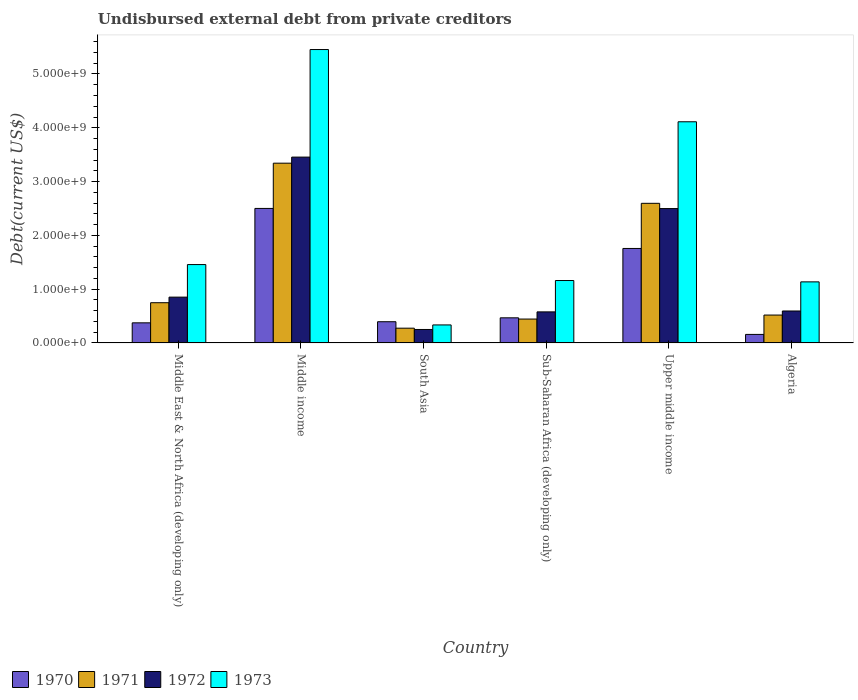How many different coloured bars are there?
Ensure brevity in your answer.  4. Are the number of bars on each tick of the X-axis equal?
Provide a succinct answer. Yes. What is the label of the 5th group of bars from the left?
Provide a short and direct response. Upper middle income. In how many cases, is the number of bars for a given country not equal to the number of legend labels?
Provide a short and direct response. 0. What is the total debt in 1973 in Algeria?
Provide a succinct answer. 1.14e+09. Across all countries, what is the maximum total debt in 1973?
Keep it short and to the point. 5.45e+09. Across all countries, what is the minimum total debt in 1971?
Provide a succinct answer. 2.74e+08. In which country was the total debt in 1972 minimum?
Your response must be concise. South Asia. What is the total total debt in 1971 in the graph?
Your answer should be very brief. 7.92e+09. What is the difference between the total debt in 1972 in Middle East & North Africa (developing only) and that in Upper middle income?
Your answer should be compact. -1.65e+09. What is the difference between the total debt in 1973 in South Asia and the total debt in 1972 in Middle East & North Africa (developing only)?
Provide a short and direct response. -5.17e+08. What is the average total debt in 1972 per country?
Keep it short and to the point. 1.37e+09. What is the difference between the total debt of/in 1970 and total debt of/in 1972 in Middle income?
Provide a succinct answer. -9.54e+08. In how many countries, is the total debt in 1972 greater than 3800000000 US$?
Make the answer very short. 0. What is the ratio of the total debt in 1972 in Middle East & North Africa (developing only) to that in Sub-Saharan Africa (developing only)?
Keep it short and to the point. 1.47. Is the total debt in 1971 in Middle East & North Africa (developing only) less than that in Upper middle income?
Offer a terse response. Yes. What is the difference between the highest and the second highest total debt in 1970?
Ensure brevity in your answer.  -7.44e+08. What is the difference between the highest and the lowest total debt in 1972?
Make the answer very short. 3.20e+09. In how many countries, is the total debt in 1970 greater than the average total debt in 1970 taken over all countries?
Your answer should be very brief. 2. What does the 3rd bar from the right in Middle East & North Africa (developing only) represents?
Provide a succinct answer. 1971. Is it the case that in every country, the sum of the total debt in 1971 and total debt in 1970 is greater than the total debt in 1972?
Provide a short and direct response. Yes. How many countries are there in the graph?
Your answer should be compact. 6. How many legend labels are there?
Make the answer very short. 4. How are the legend labels stacked?
Give a very brief answer. Horizontal. What is the title of the graph?
Give a very brief answer. Undisbursed external debt from private creditors. What is the label or title of the Y-axis?
Keep it short and to the point. Debt(current US$). What is the Debt(current US$) of 1970 in Middle East & North Africa (developing only)?
Provide a succinct answer. 3.74e+08. What is the Debt(current US$) in 1971 in Middle East & North Africa (developing only)?
Your answer should be compact. 7.48e+08. What is the Debt(current US$) in 1972 in Middle East & North Africa (developing only)?
Provide a short and direct response. 8.51e+08. What is the Debt(current US$) in 1973 in Middle East & North Africa (developing only)?
Keep it short and to the point. 1.46e+09. What is the Debt(current US$) in 1970 in Middle income?
Provide a succinct answer. 2.50e+09. What is the Debt(current US$) of 1971 in Middle income?
Ensure brevity in your answer.  3.34e+09. What is the Debt(current US$) in 1972 in Middle income?
Offer a terse response. 3.45e+09. What is the Debt(current US$) of 1973 in Middle income?
Offer a terse response. 5.45e+09. What is the Debt(current US$) of 1970 in South Asia?
Your response must be concise. 3.94e+08. What is the Debt(current US$) in 1971 in South Asia?
Make the answer very short. 2.74e+08. What is the Debt(current US$) in 1972 in South Asia?
Ensure brevity in your answer.  2.50e+08. What is the Debt(current US$) in 1973 in South Asia?
Give a very brief answer. 3.35e+08. What is the Debt(current US$) in 1970 in Sub-Saharan Africa (developing only)?
Your answer should be very brief. 4.67e+08. What is the Debt(current US$) in 1971 in Sub-Saharan Africa (developing only)?
Provide a short and direct response. 4.44e+08. What is the Debt(current US$) of 1972 in Sub-Saharan Africa (developing only)?
Offer a terse response. 5.77e+08. What is the Debt(current US$) in 1973 in Sub-Saharan Africa (developing only)?
Give a very brief answer. 1.16e+09. What is the Debt(current US$) of 1970 in Upper middle income?
Your answer should be very brief. 1.76e+09. What is the Debt(current US$) of 1971 in Upper middle income?
Your response must be concise. 2.60e+09. What is the Debt(current US$) in 1972 in Upper middle income?
Your response must be concise. 2.50e+09. What is the Debt(current US$) in 1973 in Upper middle income?
Keep it short and to the point. 4.11e+09. What is the Debt(current US$) of 1970 in Algeria?
Ensure brevity in your answer.  1.59e+08. What is the Debt(current US$) of 1971 in Algeria?
Your answer should be very brief. 5.18e+08. What is the Debt(current US$) of 1972 in Algeria?
Provide a short and direct response. 5.94e+08. What is the Debt(current US$) in 1973 in Algeria?
Provide a succinct answer. 1.14e+09. Across all countries, what is the maximum Debt(current US$) of 1970?
Your response must be concise. 2.50e+09. Across all countries, what is the maximum Debt(current US$) of 1971?
Provide a succinct answer. 3.34e+09. Across all countries, what is the maximum Debt(current US$) in 1972?
Offer a very short reply. 3.45e+09. Across all countries, what is the maximum Debt(current US$) of 1973?
Your response must be concise. 5.45e+09. Across all countries, what is the minimum Debt(current US$) of 1970?
Your answer should be compact. 1.59e+08. Across all countries, what is the minimum Debt(current US$) of 1971?
Provide a short and direct response. 2.74e+08. Across all countries, what is the minimum Debt(current US$) in 1972?
Ensure brevity in your answer.  2.50e+08. Across all countries, what is the minimum Debt(current US$) in 1973?
Make the answer very short. 3.35e+08. What is the total Debt(current US$) of 1970 in the graph?
Your answer should be very brief. 5.65e+09. What is the total Debt(current US$) of 1971 in the graph?
Offer a very short reply. 7.92e+09. What is the total Debt(current US$) of 1972 in the graph?
Provide a succinct answer. 8.23e+09. What is the total Debt(current US$) of 1973 in the graph?
Offer a terse response. 1.37e+1. What is the difference between the Debt(current US$) in 1970 in Middle East & North Africa (developing only) and that in Middle income?
Make the answer very short. -2.13e+09. What is the difference between the Debt(current US$) in 1971 in Middle East & North Africa (developing only) and that in Middle income?
Ensure brevity in your answer.  -2.59e+09. What is the difference between the Debt(current US$) of 1972 in Middle East & North Africa (developing only) and that in Middle income?
Your answer should be very brief. -2.60e+09. What is the difference between the Debt(current US$) of 1973 in Middle East & North Africa (developing only) and that in Middle income?
Give a very brief answer. -4.00e+09. What is the difference between the Debt(current US$) in 1970 in Middle East & North Africa (developing only) and that in South Asia?
Offer a terse response. -2.07e+07. What is the difference between the Debt(current US$) in 1971 in Middle East & North Africa (developing only) and that in South Asia?
Provide a short and direct response. 4.74e+08. What is the difference between the Debt(current US$) in 1972 in Middle East & North Africa (developing only) and that in South Asia?
Provide a succinct answer. 6.01e+08. What is the difference between the Debt(current US$) in 1973 in Middle East & North Africa (developing only) and that in South Asia?
Ensure brevity in your answer.  1.12e+09. What is the difference between the Debt(current US$) in 1970 in Middle East & North Africa (developing only) and that in Sub-Saharan Africa (developing only)?
Offer a very short reply. -9.32e+07. What is the difference between the Debt(current US$) of 1971 in Middle East & North Africa (developing only) and that in Sub-Saharan Africa (developing only)?
Provide a succinct answer. 3.04e+08. What is the difference between the Debt(current US$) of 1972 in Middle East & North Africa (developing only) and that in Sub-Saharan Africa (developing only)?
Ensure brevity in your answer.  2.74e+08. What is the difference between the Debt(current US$) in 1973 in Middle East & North Africa (developing only) and that in Sub-Saharan Africa (developing only)?
Your answer should be compact. 2.97e+08. What is the difference between the Debt(current US$) of 1970 in Middle East & North Africa (developing only) and that in Upper middle income?
Your answer should be compact. -1.38e+09. What is the difference between the Debt(current US$) of 1971 in Middle East & North Africa (developing only) and that in Upper middle income?
Your response must be concise. -1.85e+09. What is the difference between the Debt(current US$) of 1972 in Middle East & North Africa (developing only) and that in Upper middle income?
Make the answer very short. -1.65e+09. What is the difference between the Debt(current US$) in 1973 in Middle East & North Africa (developing only) and that in Upper middle income?
Give a very brief answer. -2.65e+09. What is the difference between the Debt(current US$) in 1970 in Middle East & North Africa (developing only) and that in Algeria?
Make the answer very short. 2.15e+08. What is the difference between the Debt(current US$) of 1971 in Middle East & North Africa (developing only) and that in Algeria?
Give a very brief answer. 2.29e+08. What is the difference between the Debt(current US$) of 1972 in Middle East & North Africa (developing only) and that in Algeria?
Your answer should be very brief. 2.57e+08. What is the difference between the Debt(current US$) of 1973 in Middle East & North Africa (developing only) and that in Algeria?
Your answer should be compact. 3.22e+08. What is the difference between the Debt(current US$) of 1970 in Middle income and that in South Asia?
Provide a succinct answer. 2.11e+09. What is the difference between the Debt(current US$) of 1971 in Middle income and that in South Asia?
Offer a very short reply. 3.07e+09. What is the difference between the Debt(current US$) in 1972 in Middle income and that in South Asia?
Offer a terse response. 3.20e+09. What is the difference between the Debt(current US$) in 1973 in Middle income and that in South Asia?
Your response must be concise. 5.12e+09. What is the difference between the Debt(current US$) in 1970 in Middle income and that in Sub-Saharan Africa (developing only)?
Your response must be concise. 2.03e+09. What is the difference between the Debt(current US$) in 1971 in Middle income and that in Sub-Saharan Africa (developing only)?
Provide a short and direct response. 2.90e+09. What is the difference between the Debt(current US$) of 1972 in Middle income and that in Sub-Saharan Africa (developing only)?
Offer a terse response. 2.88e+09. What is the difference between the Debt(current US$) of 1973 in Middle income and that in Sub-Saharan Africa (developing only)?
Your answer should be compact. 4.29e+09. What is the difference between the Debt(current US$) of 1970 in Middle income and that in Upper middle income?
Your answer should be very brief. 7.44e+08. What is the difference between the Debt(current US$) in 1971 in Middle income and that in Upper middle income?
Ensure brevity in your answer.  7.46e+08. What is the difference between the Debt(current US$) of 1972 in Middle income and that in Upper middle income?
Keep it short and to the point. 9.57e+08. What is the difference between the Debt(current US$) of 1973 in Middle income and that in Upper middle income?
Offer a terse response. 1.34e+09. What is the difference between the Debt(current US$) in 1970 in Middle income and that in Algeria?
Offer a terse response. 2.34e+09. What is the difference between the Debt(current US$) in 1971 in Middle income and that in Algeria?
Your answer should be compact. 2.82e+09. What is the difference between the Debt(current US$) in 1972 in Middle income and that in Algeria?
Ensure brevity in your answer.  2.86e+09. What is the difference between the Debt(current US$) of 1973 in Middle income and that in Algeria?
Provide a succinct answer. 4.32e+09. What is the difference between the Debt(current US$) in 1970 in South Asia and that in Sub-Saharan Africa (developing only)?
Provide a succinct answer. -7.26e+07. What is the difference between the Debt(current US$) of 1971 in South Asia and that in Sub-Saharan Africa (developing only)?
Offer a terse response. -1.70e+08. What is the difference between the Debt(current US$) of 1972 in South Asia and that in Sub-Saharan Africa (developing only)?
Provide a succinct answer. -3.27e+08. What is the difference between the Debt(current US$) of 1973 in South Asia and that in Sub-Saharan Africa (developing only)?
Make the answer very short. -8.26e+08. What is the difference between the Debt(current US$) in 1970 in South Asia and that in Upper middle income?
Keep it short and to the point. -1.36e+09. What is the difference between the Debt(current US$) in 1971 in South Asia and that in Upper middle income?
Ensure brevity in your answer.  -2.32e+09. What is the difference between the Debt(current US$) in 1972 in South Asia and that in Upper middle income?
Ensure brevity in your answer.  -2.25e+09. What is the difference between the Debt(current US$) of 1973 in South Asia and that in Upper middle income?
Offer a terse response. -3.78e+09. What is the difference between the Debt(current US$) in 1970 in South Asia and that in Algeria?
Make the answer very short. 2.36e+08. What is the difference between the Debt(current US$) in 1971 in South Asia and that in Algeria?
Make the answer very short. -2.44e+08. What is the difference between the Debt(current US$) in 1972 in South Asia and that in Algeria?
Offer a very short reply. -3.44e+08. What is the difference between the Debt(current US$) of 1973 in South Asia and that in Algeria?
Ensure brevity in your answer.  -8.00e+08. What is the difference between the Debt(current US$) in 1970 in Sub-Saharan Africa (developing only) and that in Upper middle income?
Provide a succinct answer. -1.29e+09. What is the difference between the Debt(current US$) of 1971 in Sub-Saharan Africa (developing only) and that in Upper middle income?
Offer a very short reply. -2.15e+09. What is the difference between the Debt(current US$) of 1972 in Sub-Saharan Africa (developing only) and that in Upper middle income?
Offer a very short reply. -1.92e+09. What is the difference between the Debt(current US$) in 1973 in Sub-Saharan Africa (developing only) and that in Upper middle income?
Ensure brevity in your answer.  -2.95e+09. What is the difference between the Debt(current US$) of 1970 in Sub-Saharan Africa (developing only) and that in Algeria?
Keep it short and to the point. 3.08e+08. What is the difference between the Debt(current US$) of 1971 in Sub-Saharan Africa (developing only) and that in Algeria?
Your response must be concise. -7.44e+07. What is the difference between the Debt(current US$) in 1972 in Sub-Saharan Africa (developing only) and that in Algeria?
Offer a terse response. -1.64e+07. What is the difference between the Debt(current US$) of 1973 in Sub-Saharan Africa (developing only) and that in Algeria?
Your response must be concise. 2.52e+07. What is the difference between the Debt(current US$) of 1970 in Upper middle income and that in Algeria?
Your response must be concise. 1.60e+09. What is the difference between the Debt(current US$) in 1971 in Upper middle income and that in Algeria?
Your answer should be very brief. 2.08e+09. What is the difference between the Debt(current US$) of 1972 in Upper middle income and that in Algeria?
Your answer should be compact. 1.90e+09. What is the difference between the Debt(current US$) of 1973 in Upper middle income and that in Algeria?
Give a very brief answer. 2.98e+09. What is the difference between the Debt(current US$) of 1970 in Middle East & North Africa (developing only) and the Debt(current US$) of 1971 in Middle income?
Ensure brevity in your answer.  -2.97e+09. What is the difference between the Debt(current US$) in 1970 in Middle East & North Africa (developing only) and the Debt(current US$) in 1972 in Middle income?
Offer a terse response. -3.08e+09. What is the difference between the Debt(current US$) of 1970 in Middle East & North Africa (developing only) and the Debt(current US$) of 1973 in Middle income?
Offer a terse response. -5.08e+09. What is the difference between the Debt(current US$) in 1971 in Middle East & North Africa (developing only) and the Debt(current US$) in 1972 in Middle income?
Ensure brevity in your answer.  -2.71e+09. What is the difference between the Debt(current US$) of 1971 in Middle East & North Africa (developing only) and the Debt(current US$) of 1973 in Middle income?
Keep it short and to the point. -4.71e+09. What is the difference between the Debt(current US$) of 1972 in Middle East & North Africa (developing only) and the Debt(current US$) of 1973 in Middle income?
Your response must be concise. -4.60e+09. What is the difference between the Debt(current US$) of 1970 in Middle East & North Africa (developing only) and the Debt(current US$) of 1971 in South Asia?
Make the answer very short. 9.92e+07. What is the difference between the Debt(current US$) of 1970 in Middle East & North Africa (developing only) and the Debt(current US$) of 1972 in South Asia?
Make the answer very short. 1.23e+08. What is the difference between the Debt(current US$) in 1970 in Middle East & North Africa (developing only) and the Debt(current US$) in 1973 in South Asia?
Your answer should be very brief. 3.88e+07. What is the difference between the Debt(current US$) in 1971 in Middle East & North Africa (developing only) and the Debt(current US$) in 1972 in South Asia?
Your answer should be very brief. 4.98e+08. What is the difference between the Debt(current US$) of 1971 in Middle East & North Africa (developing only) and the Debt(current US$) of 1973 in South Asia?
Offer a terse response. 4.13e+08. What is the difference between the Debt(current US$) in 1972 in Middle East & North Africa (developing only) and the Debt(current US$) in 1973 in South Asia?
Offer a very short reply. 5.17e+08. What is the difference between the Debt(current US$) in 1970 in Middle East & North Africa (developing only) and the Debt(current US$) in 1971 in Sub-Saharan Africa (developing only)?
Offer a terse response. -7.04e+07. What is the difference between the Debt(current US$) of 1970 in Middle East & North Africa (developing only) and the Debt(current US$) of 1972 in Sub-Saharan Africa (developing only)?
Offer a terse response. -2.04e+08. What is the difference between the Debt(current US$) in 1970 in Middle East & North Africa (developing only) and the Debt(current US$) in 1973 in Sub-Saharan Africa (developing only)?
Your answer should be very brief. -7.87e+08. What is the difference between the Debt(current US$) of 1971 in Middle East & North Africa (developing only) and the Debt(current US$) of 1972 in Sub-Saharan Africa (developing only)?
Provide a short and direct response. 1.70e+08. What is the difference between the Debt(current US$) in 1971 in Middle East & North Africa (developing only) and the Debt(current US$) in 1973 in Sub-Saharan Africa (developing only)?
Your answer should be compact. -4.12e+08. What is the difference between the Debt(current US$) of 1972 in Middle East & North Africa (developing only) and the Debt(current US$) of 1973 in Sub-Saharan Africa (developing only)?
Provide a short and direct response. -3.09e+08. What is the difference between the Debt(current US$) of 1970 in Middle East & North Africa (developing only) and the Debt(current US$) of 1971 in Upper middle income?
Make the answer very short. -2.22e+09. What is the difference between the Debt(current US$) of 1970 in Middle East & North Africa (developing only) and the Debt(current US$) of 1972 in Upper middle income?
Provide a succinct answer. -2.12e+09. What is the difference between the Debt(current US$) in 1970 in Middle East & North Africa (developing only) and the Debt(current US$) in 1973 in Upper middle income?
Your answer should be very brief. -3.74e+09. What is the difference between the Debt(current US$) of 1971 in Middle East & North Africa (developing only) and the Debt(current US$) of 1972 in Upper middle income?
Keep it short and to the point. -1.75e+09. What is the difference between the Debt(current US$) of 1971 in Middle East & North Africa (developing only) and the Debt(current US$) of 1973 in Upper middle income?
Give a very brief answer. -3.36e+09. What is the difference between the Debt(current US$) of 1972 in Middle East & North Africa (developing only) and the Debt(current US$) of 1973 in Upper middle income?
Provide a short and direct response. -3.26e+09. What is the difference between the Debt(current US$) in 1970 in Middle East & North Africa (developing only) and the Debt(current US$) in 1971 in Algeria?
Give a very brief answer. -1.45e+08. What is the difference between the Debt(current US$) in 1970 in Middle East & North Africa (developing only) and the Debt(current US$) in 1972 in Algeria?
Give a very brief answer. -2.20e+08. What is the difference between the Debt(current US$) of 1970 in Middle East & North Africa (developing only) and the Debt(current US$) of 1973 in Algeria?
Offer a terse response. -7.62e+08. What is the difference between the Debt(current US$) in 1971 in Middle East & North Africa (developing only) and the Debt(current US$) in 1972 in Algeria?
Offer a very short reply. 1.54e+08. What is the difference between the Debt(current US$) in 1971 in Middle East & North Africa (developing only) and the Debt(current US$) in 1973 in Algeria?
Your answer should be compact. -3.87e+08. What is the difference between the Debt(current US$) in 1972 in Middle East & North Africa (developing only) and the Debt(current US$) in 1973 in Algeria?
Make the answer very short. -2.84e+08. What is the difference between the Debt(current US$) in 1970 in Middle income and the Debt(current US$) in 1971 in South Asia?
Make the answer very short. 2.23e+09. What is the difference between the Debt(current US$) of 1970 in Middle income and the Debt(current US$) of 1972 in South Asia?
Your response must be concise. 2.25e+09. What is the difference between the Debt(current US$) in 1970 in Middle income and the Debt(current US$) in 1973 in South Asia?
Offer a very short reply. 2.17e+09. What is the difference between the Debt(current US$) in 1971 in Middle income and the Debt(current US$) in 1972 in South Asia?
Your answer should be very brief. 3.09e+09. What is the difference between the Debt(current US$) in 1971 in Middle income and the Debt(current US$) in 1973 in South Asia?
Keep it short and to the point. 3.01e+09. What is the difference between the Debt(current US$) in 1972 in Middle income and the Debt(current US$) in 1973 in South Asia?
Provide a succinct answer. 3.12e+09. What is the difference between the Debt(current US$) in 1970 in Middle income and the Debt(current US$) in 1971 in Sub-Saharan Africa (developing only)?
Make the answer very short. 2.06e+09. What is the difference between the Debt(current US$) in 1970 in Middle income and the Debt(current US$) in 1972 in Sub-Saharan Africa (developing only)?
Offer a terse response. 1.92e+09. What is the difference between the Debt(current US$) in 1970 in Middle income and the Debt(current US$) in 1973 in Sub-Saharan Africa (developing only)?
Offer a terse response. 1.34e+09. What is the difference between the Debt(current US$) of 1971 in Middle income and the Debt(current US$) of 1972 in Sub-Saharan Africa (developing only)?
Keep it short and to the point. 2.76e+09. What is the difference between the Debt(current US$) of 1971 in Middle income and the Debt(current US$) of 1973 in Sub-Saharan Africa (developing only)?
Make the answer very short. 2.18e+09. What is the difference between the Debt(current US$) in 1972 in Middle income and the Debt(current US$) in 1973 in Sub-Saharan Africa (developing only)?
Keep it short and to the point. 2.29e+09. What is the difference between the Debt(current US$) in 1970 in Middle income and the Debt(current US$) in 1971 in Upper middle income?
Provide a short and direct response. -9.50e+07. What is the difference between the Debt(current US$) of 1970 in Middle income and the Debt(current US$) of 1972 in Upper middle income?
Provide a succinct answer. 2.49e+06. What is the difference between the Debt(current US$) of 1970 in Middle income and the Debt(current US$) of 1973 in Upper middle income?
Your answer should be very brief. -1.61e+09. What is the difference between the Debt(current US$) in 1971 in Middle income and the Debt(current US$) in 1972 in Upper middle income?
Provide a short and direct response. 8.44e+08. What is the difference between the Debt(current US$) in 1971 in Middle income and the Debt(current US$) in 1973 in Upper middle income?
Provide a succinct answer. -7.70e+08. What is the difference between the Debt(current US$) of 1972 in Middle income and the Debt(current US$) of 1973 in Upper middle income?
Ensure brevity in your answer.  -6.57e+08. What is the difference between the Debt(current US$) of 1970 in Middle income and the Debt(current US$) of 1971 in Algeria?
Provide a short and direct response. 1.98e+09. What is the difference between the Debt(current US$) of 1970 in Middle income and the Debt(current US$) of 1972 in Algeria?
Your response must be concise. 1.91e+09. What is the difference between the Debt(current US$) in 1970 in Middle income and the Debt(current US$) in 1973 in Algeria?
Ensure brevity in your answer.  1.37e+09. What is the difference between the Debt(current US$) of 1971 in Middle income and the Debt(current US$) of 1972 in Algeria?
Give a very brief answer. 2.75e+09. What is the difference between the Debt(current US$) of 1971 in Middle income and the Debt(current US$) of 1973 in Algeria?
Your response must be concise. 2.21e+09. What is the difference between the Debt(current US$) in 1972 in Middle income and the Debt(current US$) in 1973 in Algeria?
Offer a very short reply. 2.32e+09. What is the difference between the Debt(current US$) in 1970 in South Asia and the Debt(current US$) in 1971 in Sub-Saharan Africa (developing only)?
Give a very brief answer. -4.98e+07. What is the difference between the Debt(current US$) of 1970 in South Asia and the Debt(current US$) of 1972 in Sub-Saharan Africa (developing only)?
Your response must be concise. -1.83e+08. What is the difference between the Debt(current US$) of 1970 in South Asia and the Debt(current US$) of 1973 in Sub-Saharan Africa (developing only)?
Provide a succinct answer. -7.66e+08. What is the difference between the Debt(current US$) of 1971 in South Asia and the Debt(current US$) of 1972 in Sub-Saharan Africa (developing only)?
Your answer should be very brief. -3.03e+08. What is the difference between the Debt(current US$) of 1971 in South Asia and the Debt(current US$) of 1973 in Sub-Saharan Africa (developing only)?
Your response must be concise. -8.86e+08. What is the difference between the Debt(current US$) of 1972 in South Asia and the Debt(current US$) of 1973 in Sub-Saharan Africa (developing only)?
Your answer should be very brief. -9.10e+08. What is the difference between the Debt(current US$) of 1970 in South Asia and the Debt(current US$) of 1971 in Upper middle income?
Your response must be concise. -2.20e+09. What is the difference between the Debt(current US$) in 1970 in South Asia and the Debt(current US$) in 1972 in Upper middle income?
Your response must be concise. -2.10e+09. What is the difference between the Debt(current US$) in 1970 in South Asia and the Debt(current US$) in 1973 in Upper middle income?
Give a very brief answer. -3.72e+09. What is the difference between the Debt(current US$) of 1971 in South Asia and the Debt(current US$) of 1972 in Upper middle income?
Provide a succinct answer. -2.22e+09. What is the difference between the Debt(current US$) of 1971 in South Asia and the Debt(current US$) of 1973 in Upper middle income?
Your answer should be very brief. -3.84e+09. What is the difference between the Debt(current US$) in 1972 in South Asia and the Debt(current US$) in 1973 in Upper middle income?
Provide a short and direct response. -3.86e+09. What is the difference between the Debt(current US$) in 1970 in South Asia and the Debt(current US$) in 1971 in Algeria?
Make the answer very short. -1.24e+08. What is the difference between the Debt(current US$) in 1970 in South Asia and the Debt(current US$) in 1972 in Algeria?
Your answer should be very brief. -2.00e+08. What is the difference between the Debt(current US$) of 1970 in South Asia and the Debt(current US$) of 1973 in Algeria?
Provide a short and direct response. -7.41e+08. What is the difference between the Debt(current US$) of 1971 in South Asia and the Debt(current US$) of 1972 in Algeria?
Your answer should be compact. -3.20e+08. What is the difference between the Debt(current US$) of 1971 in South Asia and the Debt(current US$) of 1973 in Algeria?
Give a very brief answer. -8.61e+08. What is the difference between the Debt(current US$) in 1972 in South Asia and the Debt(current US$) in 1973 in Algeria?
Provide a succinct answer. -8.85e+08. What is the difference between the Debt(current US$) of 1970 in Sub-Saharan Africa (developing only) and the Debt(current US$) of 1971 in Upper middle income?
Make the answer very short. -2.13e+09. What is the difference between the Debt(current US$) in 1970 in Sub-Saharan Africa (developing only) and the Debt(current US$) in 1972 in Upper middle income?
Give a very brief answer. -2.03e+09. What is the difference between the Debt(current US$) in 1970 in Sub-Saharan Africa (developing only) and the Debt(current US$) in 1973 in Upper middle income?
Keep it short and to the point. -3.64e+09. What is the difference between the Debt(current US$) of 1971 in Sub-Saharan Africa (developing only) and the Debt(current US$) of 1972 in Upper middle income?
Offer a very short reply. -2.05e+09. What is the difference between the Debt(current US$) of 1971 in Sub-Saharan Africa (developing only) and the Debt(current US$) of 1973 in Upper middle income?
Ensure brevity in your answer.  -3.67e+09. What is the difference between the Debt(current US$) in 1972 in Sub-Saharan Africa (developing only) and the Debt(current US$) in 1973 in Upper middle income?
Provide a succinct answer. -3.53e+09. What is the difference between the Debt(current US$) of 1970 in Sub-Saharan Africa (developing only) and the Debt(current US$) of 1971 in Algeria?
Your answer should be very brief. -5.16e+07. What is the difference between the Debt(current US$) in 1970 in Sub-Saharan Africa (developing only) and the Debt(current US$) in 1972 in Algeria?
Ensure brevity in your answer.  -1.27e+08. What is the difference between the Debt(current US$) in 1970 in Sub-Saharan Africa (developing only) and the Debt(current US$) in 1973 in Algeria?
Give a very brief answer. -6.68e+08. What is the difference between the Debt(current US$) of 1971 in Sub-Saharan Africa (developing only) and the Debt(current US$) of 1972 in Algeria?
Provide a short and direct response. -1.50e+08. What is the difference between the Debt(current US$) of 1971 in Sub-Saharan Africa (developing only) and the Debt(current US$) of 1973 in Algeria?
Make the answer very short. -6.91e+08. What is the difference between the Debt(current US$) of 1972 in Sub-Saharan Africa (developing only) and the Debt(current US$) of 1973 in Algeria?
Offer a very short reply. -5.58e+08. What is the difference between the Debt(current US$) in 1970 in Upper middle income and the Debt(current US$) in 1971 in Algeria?
Your answer should be very brief. 1.24e+09. What is the difference between the Debt(current US$) of 1970 in Upper middle income and the Debt(current US$) of 1972 in Algeria?
Keep it short and to the point. 1.16e+09. What is the difference between the Debt(current US$) of 1970 in Upper middle income and the Debt(current US$) of 1973 in Algeria?
Offer a terse response. 6.21e+08. What is the difference between the Debt(current US$) of 1971 in Upper middle income and the Debt(current US$) of 1972 in Algeria?
Offer a terse response. 2.00e+09. What is the difference between the Debt(current US$) of 1971 in Upper middle income and the Debt(current US$) of 1973 in Algeria?
Ensure brevity in your answer.  1.46e+09. What is the difference between the Debt(current US$) in 1972 in Upper middle income and the Debt(current US$) in 1973 in Algeria?
Your response must be concise. 1.36e+09. What is the average Debt(current US$) in 1970 per country?
Your response must be concise. 9.42e+08. What is the average Debt(current US$) in 1971 per country?
Keep it short and to the point. 1.32e+09. What is the average Debt(current US$) of 1972 per country?
Offer a very short reply. 1.37e+09. What is the average Debt(current US$) in 1973 per country?
Make the answer very short. 2.28e+09. What is the difference between the Debt(current US$) in 1970 and Debt(current US$) in 1971 in Middle East & North Africa (developing only)?
Ensure brevity in your answer.  -3.74e+08. What is the difference between the Debt(current US$) of 1970 and Debt(current US$) of 1972 in Middle East & North Africa (developing only)?
Keep it short and to the point. -4.78e+08. What is the difference between the Debt(current US$) in 1970 and Debt(current US$) in 1973 in Middle East & North Africa (developing only)?
Your response must be concise. -1.08e+09. What is the difference between the Debt(current US$) in 1971 and Debt(current US$) in 1972 in Middle East & North Africa (developing only)?
Offer a very short reply. -1.04e+08. What is the difference between the Debt(current US$) in 1971 and Debt(current US$) in 1973 in Middle East & North Africa (developing only)?
Provide a succinct answer. -7.09e+08. What is the difference between the Debt(current US$) in 1972 and Debt(current US$) in 1973 in Middle East & North Africa (developing only)?
Your answer should be very brief. -6.06e+08. What is the difference between the Debt(current US$) in 1970 and Debt(current US$) in 1971 in Middle income?
Make the answer very short. -8.41e+08. What is the difference between the Debt(current US$) of 1970 and Debt(current US$) of 1972 in Middle income?
Give a very brief answer. -9.54e+08. What is the difference between the Debt(current US$) of 1970 and Debt(current US$) of 1973 in Middle income?
Your answer should be compact. -2.95e+09. What is the difference between the Debt(current US$) in 1971 and Debt(current US$) in 1972 in Middle income?
Offer a very short reply. -1.13e+08. What is the difference between the Debt(current US$) of 1971 and Debt(current US$) of 1973 in Middle income?
Provide a short and direct response. -2.11e+09. What is the difference between the Debt(current US$) of 1972 and Debt(current US$) of 1973 in Middle income?
Offer a very short reply. -2.00e+09. What is the difference between the Debt(current US$) in 1970 and Debt(current US$) in 1971 in South Asia?
Offer a very short reply. 1.20e+08. What is the difference between the Debt(current US$) of 1970 and Debt(current US$) of 1972 in South Asia?
Offer a very short reply. 1.44e+08. What is the difference between the Debt(current US$) in 1970 and Debt(current US$) in 1973 in South Asia?
Make the answer very short. 5.95e+07. What is the difference between the Debt(current US$) of 1971 and Debt(current US$) of 1972 in South Asia?
Give a very brief answer. 2.41e+07. What is the difference between the Debt(current US$) of 1971 and Debt(current US$) of 1973 in South Asia?
Ensure brevity in your answer.  -6.04e+07. What is the difference between the Debt(current US$) in 1972 and Debt(current US$) in 1973 in South Asia?
Make the answer very short. -8.45e+07. What is the difference between the Debt(current US$) of 1970 and Debt(current US$) of 1971 in Sub-Saharan Africa (developing only)?
Offer a terse response. 2.28e+07. What is the difference between the Debt(current US$) of 1970 and Debt(current US$) of 1972 in Sub-Saharan Africa (developing only)?
Ensure brevity in your answer.  -1.11e+08. What is the difference between the Debt(current US$) in 1970 and Debt(current US$) in 1973 in Sub-Saharan Africa (developing only)?
Ensure brevity in your answer.  -6.94e+08. What is the difference between the Debt(current US$) of 1971 and Debt(current US$) of 1972 in Sub-Saharan Africa (developing only)?
Make the answer very short. -1.33e+08. What is the difference between the Debt(current US$) in 1971 and Debt(current US$) in 1973 in Sub-Saharan Africa (developing only)?
Ensure brevity in your answer.  -7.16e+08. What is the difference between the Debt(current US$) in 1972 and Debt(current US$) in 1973 in Sub-Saharan Africa (developing only)?
Your answer should be very brief. -5.83e+08. What is the difference between the Debt(current US$) of 1970 and Debt(current US$) of 1971 in Upper middle income?
Your response must be concise. -8.39e+08. What is the difference between the Debt(current US$) of 1970 and Debt(current US$) of 1972 in Upper middle income?
Make the answer very short. -7.42e+08. What is the difference between the Debt(current US$) in 1970 and Debt(current US$) in 1973 in Upper middle income?
Provide a short and direct response. -2.36e+09. What is the difference between the Debt(current US$) in 1971 and Debt(current US$) in 1972 in Upper middle income?
Keep it short and to the point. 9.75e+07. What is the difference between the Debt(current US$) of 1971 and Debt(current US$) of 1973 in Upper middle income?
Offer a very short reply. -1.52e+09. What is the difference between the Debt(current US$) of 1972 and Debt(current US$) of 1973 in Upper middle income?
Provide a succinct answer. -1.61e+09. What is the difference between the Debt(current US$) of 1970 and Debt(current US$) of 1971 in Algeria?
Offer a very short reply. -3.60e+08. What is the difference between the Debt(current US$) of 1970 and Debt(current US$) of 1972 in Algeria?
Give a very brief answer. -4.35e+08. What is the difference between the Debt(current US$) in 1970 and Debt(current US$) in 1973 in Algeria?
Provide a short and direct response. -9.77e+08. What is the difference between the Debt(current US$) in 1971 and Debt(current US$) in 1972 in Algeria?
Provide a short and direct response. -7.55e+07. What is the difference between the Debt(current US$) in 1971 and Debt(current US$) in 1973 in Algeria?
Your response must be concise. -6.17e+08. What is the difference between the Debt(current US$) in 1972 and Debt(current US$) in 1973 in Algeria?
Give a very brief answer. -5.41e+08. What is the ratio of the Debt(current US$) of 1970 in Middle East & North Africa (developing only) to that in Middle income?
Provide a succinct answer. 0.15. What is the ratio of the Debt(current US$) of 1971 in Middle East & North Africa (developing only) to that in Middle income?
Ensure brevity in your answer.  0.22. What is the ratio of the Debt(current US$) of 1972 in Middle East & North Africa (developing only) to that in Middle income?
Keep it short and to the point. 0.25. What is the ratio of the Debt(current US$) of 1973 in Middle East & North Africa (developing only) to that in Middle income?
Offer a terse response. 0.27. What is the ratio of the Debt(current US$) of 1970 in Middle East & North Africa (developing only) to that in South Asia?
Offer a very short reply. 0.95. What is the ratio of the Debt(current US$) in 1971 in Middle East & North Africa (developing only) to that in South Asia?
Ensure brevity in your answer.  2.73. What is the ratio of the Debt(current US$) of 1972 in Middle East & North Africa (developing only) to that in South Asia?
Your response must be concise. 3.4. What is the ratio of the Debt(current US$) in 1973 in Middle East & North Africa (developing only) to that in South Asia?
Your answer should be very brief. 4.35. What is the ratio of the Debt(current US$) of 1970 in Middle East & North Africa (developing only) to that in Sub-Saharan Africa (developing only)?
Provide a short and direct response. 0.8. What is the ratio of the Debt(current US$) in 1971 in Middle East & North Africa (developing only) to that in Sub-Saharan Africa (developing only)?
Provide a succinct answer. 1.68. What is the ratio of the Debt(current US$) in 1972 in Middle East & North Africa (developing only) to that in Sub-Saharan Africa (developing only)?
Offer a terse response. 1.47. What is the ratio of the Debt(current US$) of 1973 in Middle East & North Africa (developing only) to that in Sub-Saharan Africa (developing only)?
Provide a succinct answer. 1.26. What is the ratio of the Debt(current US$) of 1970 in Middle East & North Africa (developing only) to that in Upper middle income?
Provide a succinct answer. 0.21. What is the ratio of the Debt(current US$) in 1971 in Middle East & North Africa (developing only) to that in Upper middle income?
Provide a short and direct response. 0.29. What is the ratio of the Debt(current US$) of 1972 in Middle East & North Africa (developing only) to that in Upper middle income?
Give a very brief answer. 0.34. What is the ratio of the Debt(current US$) in 1973 in Middle East & North Africa (developing only) to that in Upper middle income?
Offer a terse response. 0.35. What is the ratio of the Debt(current US$) of 1970 in Middle East & North Africa (developing only) to that in Algeria?
Ensure brevity in your answer.  2.36. What is the ratio of the Debt(current US$) in 1971 in Middle East & North Africa (developing only) to that in Algeria?
Provide a succinct answer. 1.44. What is the ratio of the Debt(current US$) of 1972 in Middle East & North Africa (developing only) to that in Algeria?
Make the answer very short. 1.43. What is the ratio of the Debt(current US$) in 1973 in Middle East & North Africa (developing only) to that in Algeria?
Offer a terse response. 1.28. What is the ratio of the Debt(current US$) of 1970 in Middle income to that in South Asia?
Make the answer very short. 6.34. What is the ratio of the Debt(current US$) of 1971 in Middle income to that in South Asia?
Your answer should be very brief. 12.18. What is the ratio of the Debt(current US$) of 1972 in Middle income to that in South Asia?
Provide a short and direct response. 13.8. What is the ratio of the Debt(current US$) in 1973 in Middle income to that in South Asia?
Your response must be concise. 16.29. What is the ratio of the Debt(current US$) of 1970 in Middle income to that in Sub-Saharan Africa (developing only)?
Your response must be concise. 5.36. What is the ratio of the Debt(current US$) of 1971 in Middle income to that in Sub-Saharan Africa (developing only)?
Provide a succinct answer. 7.53. What is the ratio of the Debt(current US$) in 1972 in Middle income to that in Sub-Saharan Africa (developing only)?
Provide a succinct answer. 5.98. What is the ratio of the Debt(current US$) of 1973 in Middle income to that in Sub-Saharan Africa (developing only)?
Keep it short and to the point. 4.7. What is the ratio of the Debt(current US$) in 1970 in Middle income to that in Upper middle income?
Offer a very short reply. 1.42. What is the ratio of the Debt(current US$) of 1971 in Middle income to that in Upper middle income?
Your answer should be compact. 1.29. What is the ratio of the Debt(current US$) in 1972 in Middle income to that in Upper middle income?
Give a very brief answer. 1.38. What is the ratio of the Debt(current US$) in 1973 in Middle income to that in Upper middle income?
Your response must be concise. 1.33. What is the ratio of the Debt(current US$) in 1970 in Middle income to that in Algeria?
Your answer should be very brief. 15.77. What is the ratio of the Debt(current US$) in 1971 in Middle income to that in Algeria?
Provide a succinct answer. 6.45. What is the ratio of the Debt(current US$) of 1972 in Middle income to that in Algeria?
Ensure brevity in your answer.  5.82. What is the ratio of the Debt(current US$) of 1973 in Middle income to that in Algeria?
Make the answer very short. 4.8. What is the ratio of the Debt(current US$) in 1970 in South Asia to that in Sub-Saharan Africa (developing only)?
Provide a short and direct response. 0.84. What is the ratio of the Debt(current US$) in 1971 in South Asia to that in Sub-Saharan Africa (developing only)?
Offer a very short reply. 0.62. What is the ratio of the Debt(current US$) in 1972 in South Asia to that in Sub-Saharan Africa (developing only)?
Provide a short and direct response. 0.43. What is the ratio of the Debt(current US$) of 1973 in South Asia to that in Sub-Saharan Africa (developing only)?
Your answer should be compact. 0.29. What is the ratio of the Debt(current US$) in 1970 in South Asia to that in Upper middle income?
Offer a terse response. 0.22. What is the ratio of the Debt(current US$) in 1971 in South Asia to that in Upper middle income?
Your answer should be compact. 0.11. What is the ratio of the Debt(current US$) in 1972 in South Asia to that in Upper middle income?
Provide a short and direct response. 0.1. What is the ratio of the Debt(current US$) in 1973 in South Asia to that in Upper middle income?
Provide a short and direct response. 0.08. What is the ratio of the Debt(current US$) of 1970 in South Asia to that in Algeria?
Your answer should be very brief. 2.49. What is the ratio of the Debt(current US$) of 1971 in South Asia to that in Algeria?
Offer a very short reply. 0.53. What is the ratio of the Debt(current US$) of 1972 in South Asia to that in Algeria?
Your response must be concise. 0.42. What is the ratio of the Debt(current US$) in 1973 in South Asia to that in Algeria?
Offer a very short reply. 0.29. What is the ratio of the Debt(current US$) of 1970 in Sub-Saharan Africa (developing only) to that in Upper middle income?
Provide a succinct answer. 0.27. What is the ratio of the Debt(current US$) in 1971 in Sub-Saharan Africa (developing only) to that in Upper middle income?
Ensure brevity in your answer.  0.17. What is the ratio of the Debt(current US$) in 1972 in Sub-Saharan Africa (developing only) to that in Upper middle income?
Give a very brief answer. 0.23. What is the ratio of the Debt(current US$) of 1973 in Sub-Saharan Africa (developing only) to that in Upper middle income?
Offer a terse response. 0.28. What is the ratio of the Debt(current US$) in 1970 in Sub-Saharan Africa (developing only) to that in Algeria?
Provide a short and direct response. 2.94. What is the ratio of the Debt(current US$) of 1971 in Sub-Saharan Africa (developing only) to that in Algeria?
Your answer should be very brief. 0.86. What is the ratio of the Debt(current US$) in 1972 in Sub-Saharan Africa (developing only) to that in Algeria?
Ensure brevity in your answer.  0.97. What is the ratio of the Debt(current US$) of 1973 in Sub-Saharan Africa (developing only) to that in Algeria?
Offer a terse response. 1.02. What is the ratio of the Debt(current US$) of 1970 in Upper middle income to that in Algeria?
Offer a very short reply. 11.08. What is the ratio of the Debt(current US$) of 1971 in Upper middle income to that in Algeria?
Your answer should be compact. 5.01. What is the ratio of the Debt(current US$) of 1972 in Upper middle income to that in Algeria?
Ensure brevity in your answer.  4.21. What is the ratio of the Debt(current US$) in 1973 in Upper middle income to that in Algeria?
Your answer should be compact. 3.62. What is the difference between the highest and the second highest Debt(current US$) of 1970?
Give a very brief answer. 7.44e+08. What is the difference between the highest and the second highest Debt(current US$) of 1971?
Your answer should be very brief. 7.46e+08. What is the difference between the highest and the second highest Debt(current US$) in 1972?
Ensure brevity in your answer.  9.57e+08. What is the difference between the highest and the second highest Debt(current US$) in 1973?
Provide a succinct answer. 1.34e+09. What is the difference between the highest and the lowest Debt(current US$) of 1970?
Provide a succinct answer. 2.34e+09. What is the difference between the highest and the lowest Debt(current US$) of 1971?
Make the answer very short. 3.07e+09. What is the difference between the highest and the lowest Debt(current US$) of 1972?
Offer a very short reply. 3.20e+09. What is the difference between the highest and the lowest Debt(current US$) in 1973?
Keep it short and to the point. 5.12e+09. 